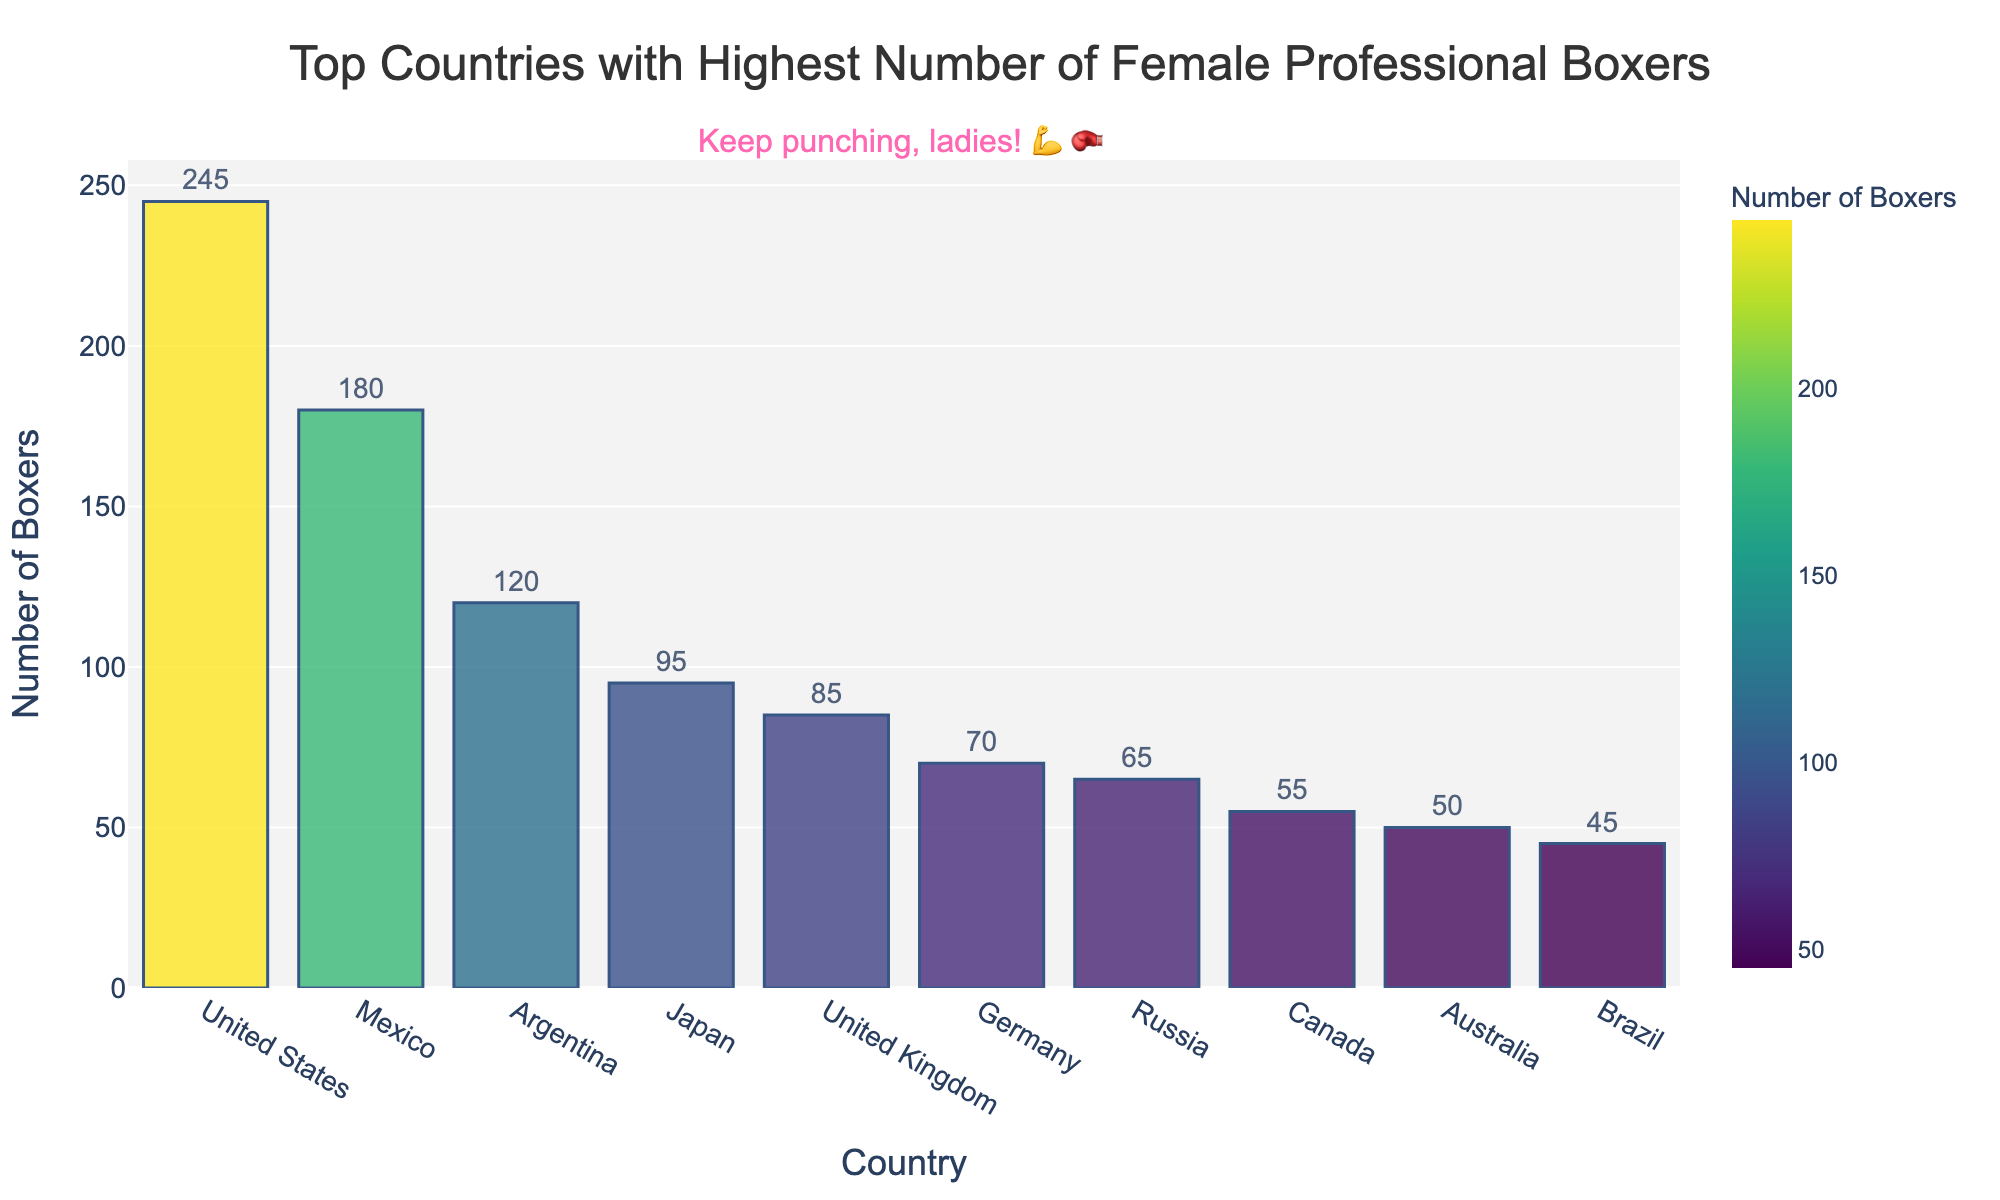Which country has the highest number of female professional boxers? The bar chart shows the number of female professional boxers for each country. The United States has the tallest bar, indicating it has the highest number.
Answer: United States How many more female professional boxers does the United States have compared to the United Kingdom? The figure shows 245 boxers for the United States and 85 for the United Kingdom. The difference is 245 - 85 = 160.
Answer: 160 What's the average number of female professional boxers for the top 5 countries? The top 5 countries are the United States (245), Mexico (180), Argentina (120), Japan (95), and the United Kingdom (85). Adding these gives 245 + 180 + 120 + 95 + 85 = 725. The average is 725 / 5 = 145.
Answer: 145 Which two countries have the closest number of female professional boxers? By visually comparing the heights of the bars, Japan (95) and the United Kingdom (85) have the closest numbers. The difference is 95 - 85 = 10.
Answer: Japan and United Kingdom What's the total number of female professional boxers in all shown countries combined? Add the numbers for all countries: 245 + 180 + 120 + 95 + 85 + 70 + 65 + 55 + 50 + 45 = 1010.
Answer: 1010 Which country ranks fourth in terms of the number of female professional boxers? By observing the heights of the bars in descending order, Japan ranks fourth after the United States, Mexico, and Argentina.
Answer: Japan How many female professional boxers do Mexico and Argentina have together? From the chart, Mexico has 180 boxers, and Argentina has 120. Their combined total is 180 + 120 = 300.
Answer: 300 Between Germany and Russia, which has fewer female professional boxers and by how much? Germany has 70, and Russia has 65. Russia has 5 fewer boxers than Germany (70 - 65 = 5).
Answer: Russia, 5 What portion of the total number of female professional boxers do the top 3 countries represent? The top 3 countries are the United States (245), Mexico (180), and Argentina (120). Their combined total is 245 + 180 + 120 = 545. The total number for all countries is 1010. The portion is calculated as 545 / 1010 ≈ 0.54 (or 54%).
Answer: 54% Which country is immediately below the United Kingdom in terms of the number of female professional boxers? The United Kingdom has 85 boxers. The next country, with a slightly smaller number, is Germany, which has 70.
Answer: Germany 